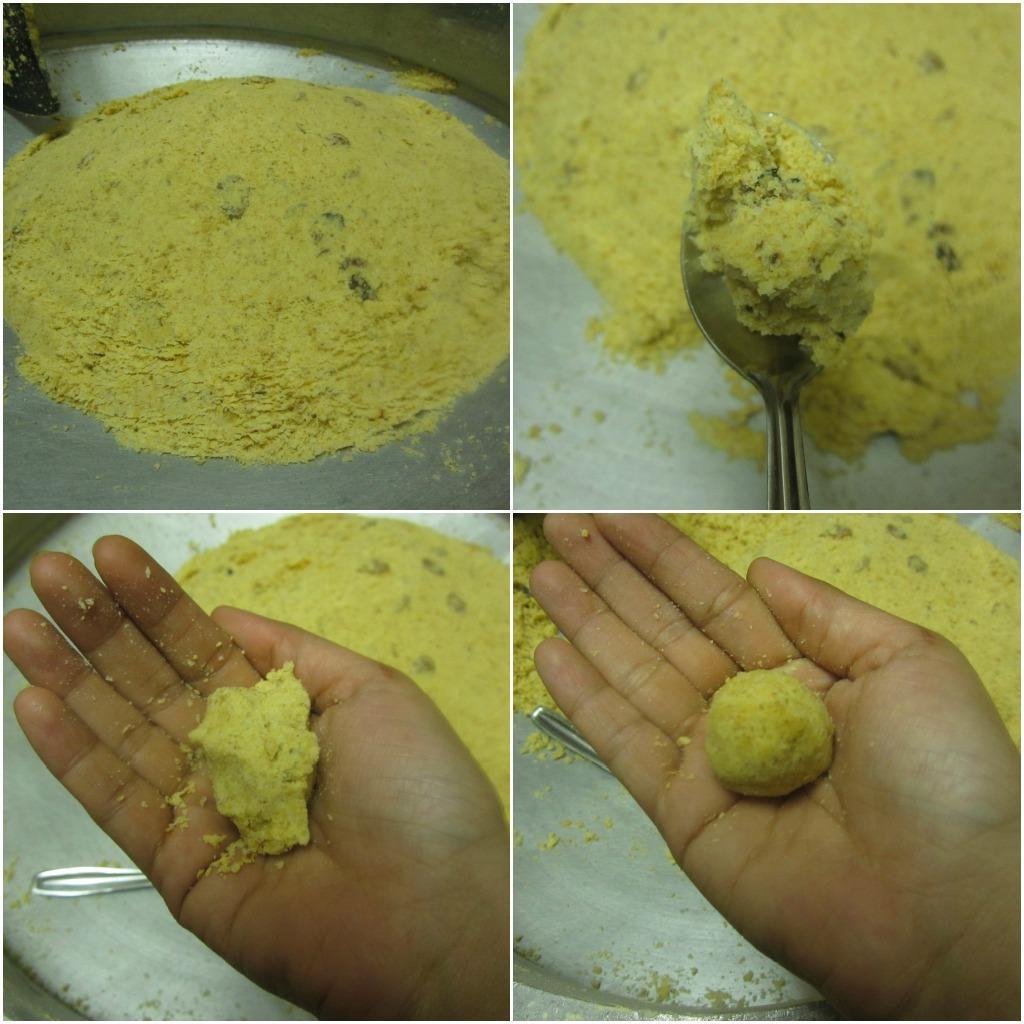Please provide a concise description of this image. This picture consists of college in the image. 